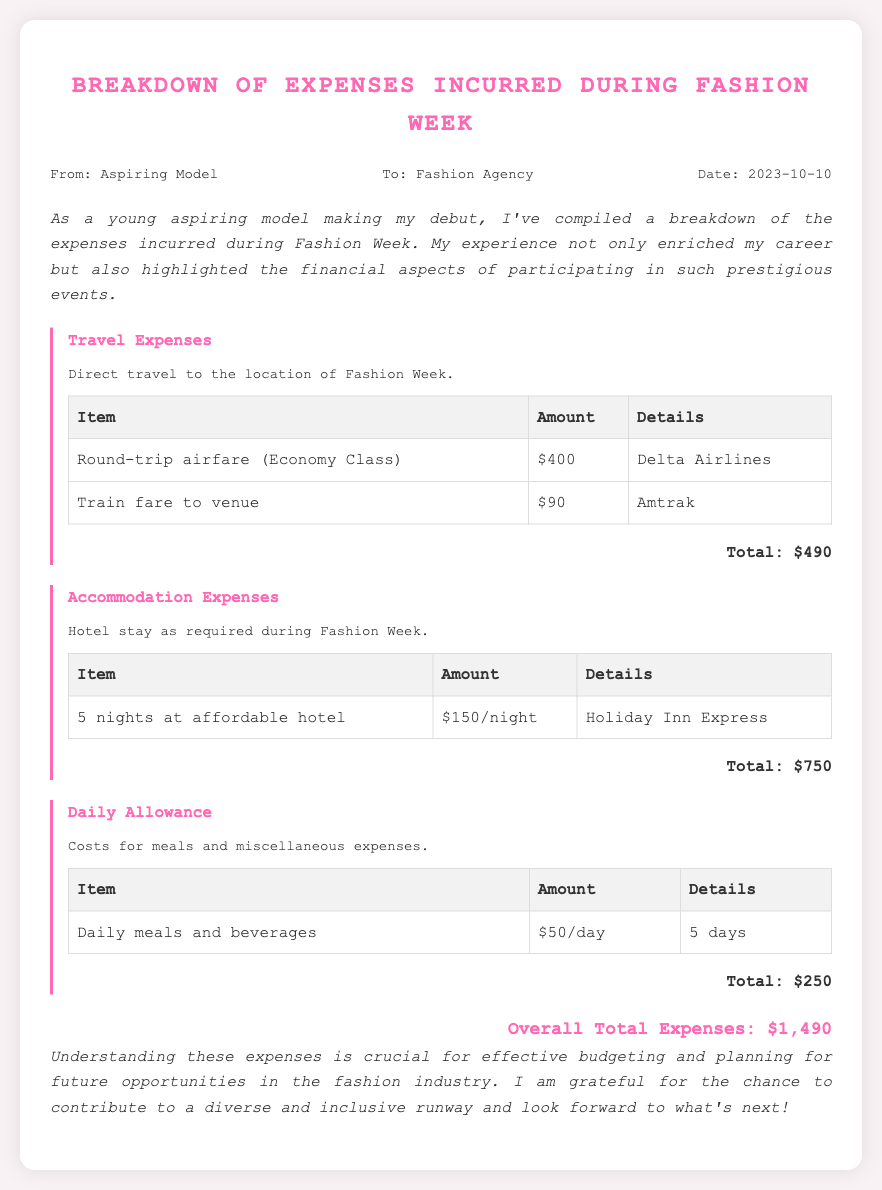what is the total travel expense? The total travel expense is the sum of the airfare and train fare, which is $400 + $90 = $490.
Answer: $490 how many nights did the model stay at the hotel? The model stayed for 5 nights at the hotel as noted in the accommodation section.
Answer: 5 nights what is the daily allowance amount? The daily allowance amount is specified as $50 per day for meals and beverages.
Answer: $50/day who is the sender of the memo? The sender, as noted at the top of the document, is identified as "Aspiring Model."
Answer: Aspiring Model what is the overall total expenses incurred? The overall total expenses are clearly stated at the end of the memo, which sums up all sections leading to $1,490.
Answer: $1,490 where did the model stay during Fashion Week? The hotel where the model stayed is mentioned as "Holiday Inn Express."
Answer: Holiday Inn Express what is the purpose of the memo? The purpose of the memo is expressed in the introduction as a breakdown of expenses incurred during Fashion Week.
Answer: Breakdown of expenses what type of travel was provided? The travel type indicated in the expenses is "Round-trip airfare (Economy Class)."
Answer: Round-trip airfare (Economy Class) 